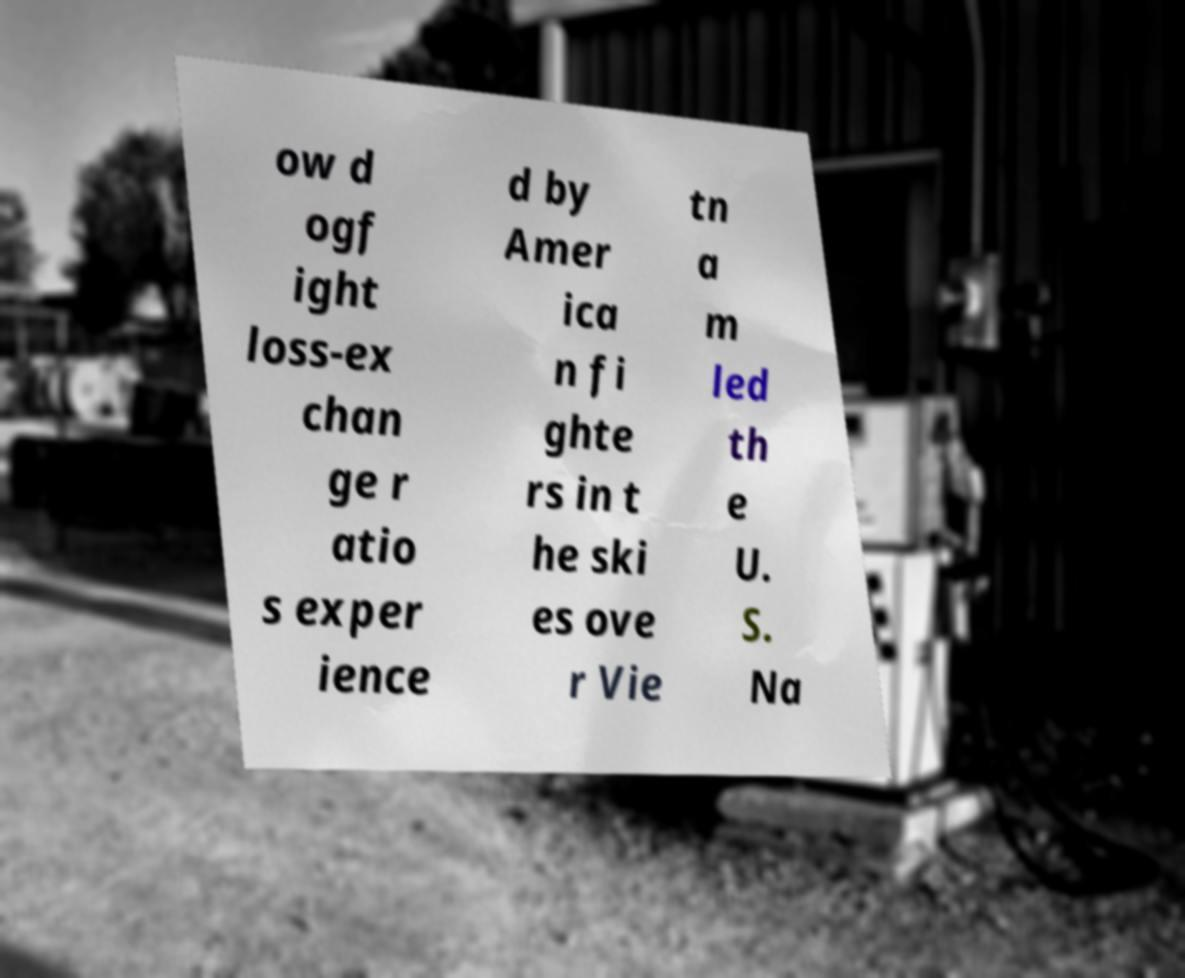Please identify and transcribe the text found in this image. ow d ogf ight loss-ex chan ge r atio s exper ience d by Amer ica n fi ghte rs in t he ski es ove r Vie tn a m led th e U. S. Na 